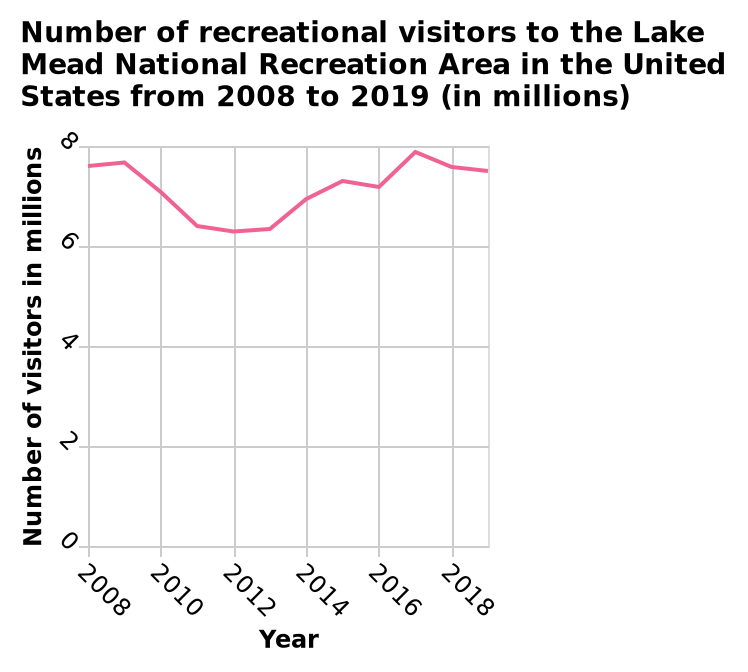<image>
When did the number of visitors to the Lake Mead National Recreation Area reach its highest point?  The highest number of visitors was in 2017. What are the minimum and maximum values on the x-axis? The minimum value on the x-axis is 2008 and the maximum value is 2018. Offer a thorough analysis of the image. The number of visitors to the Lake Mead National Recreation Area in 2008 was around 7.5 million. The number of visitors declined throughout the years until 2015 where they saw an increase of just under 7.5 million which puts the number of visitors back to a similar position in 2008. The highest number of visitors was just under 8 million in 2017. What are the minimum and maximum values on the y-axis? The minimum value on the y-axis is 0 and the maximum value is 8. 